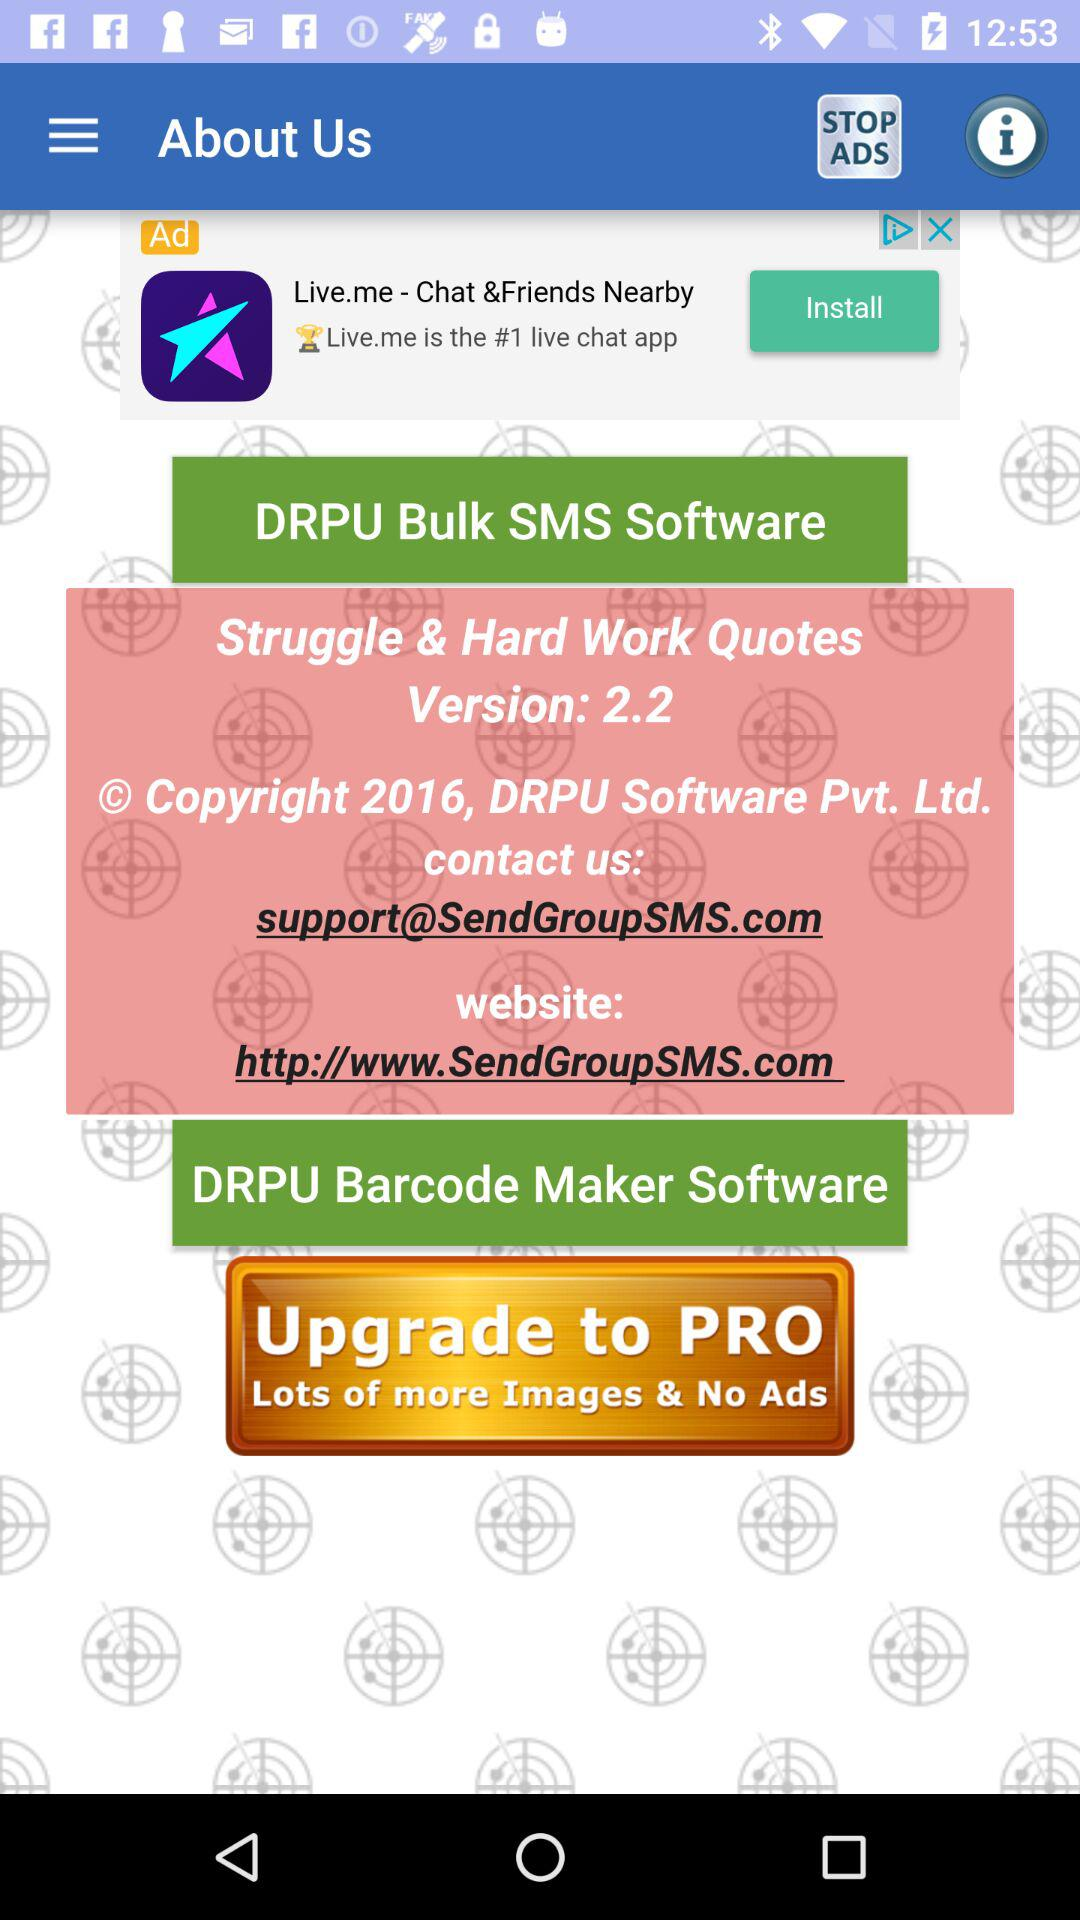Which version is given? The given version is 2.2. 